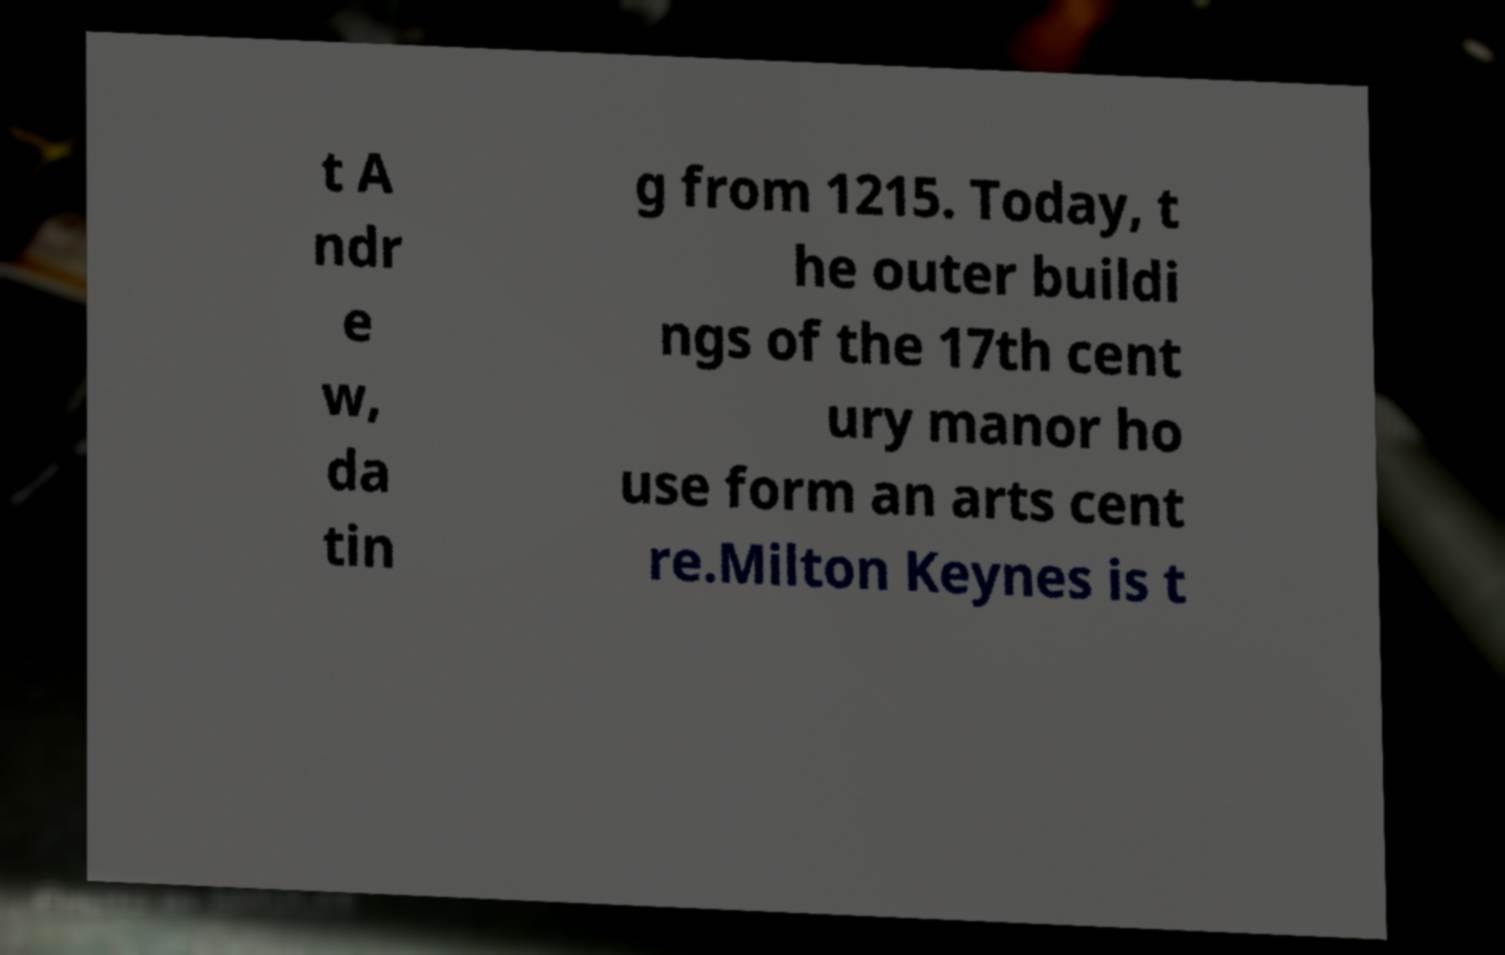I need the written content from this picture converted into text. Can you do that? t A ndr e w, da tin g from 1215. Today, t he outer buildi ngs of the 17th cent ury manor ho use form an arts cent re.Milton Keynes is t 